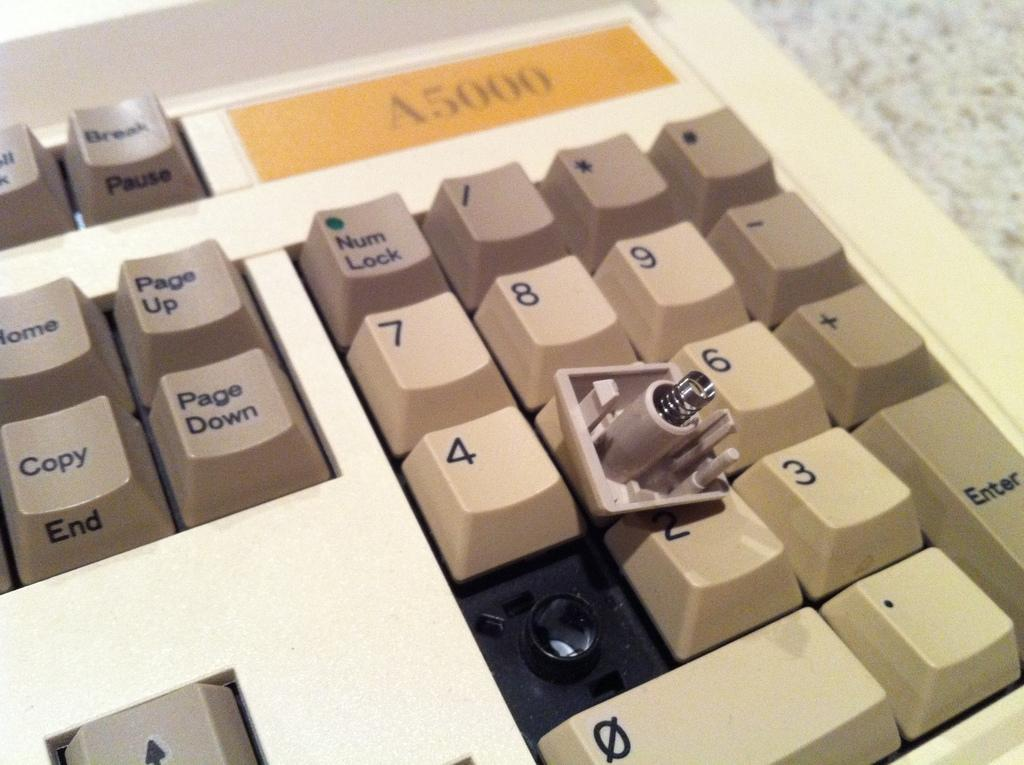<image>
Describe the image concisely. The number 1 key cap is lying upside down on a number keypad. 